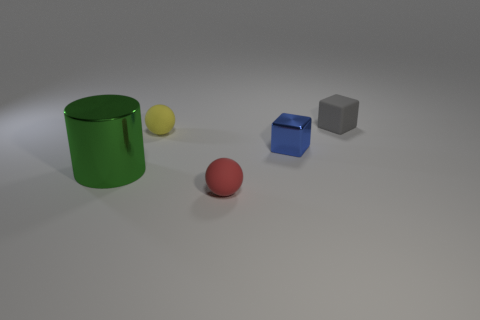Are there any other things that are the same size as the green metallic thing?
Offer a very short reply. No. Is there anything else that is the same shape as the large green metallic thing?
Your answer should be very brief. No. What number of cylinders are either red matte objects or blue metallic objects?
Provide a short and direct response. 0. There is a matte ball that is in front of the small blue block; is it the same color as the cylinder?
Your answer should be compact. No. The tiny ball that is on the left side of the ball that is in front of the ball that is behind the big green metallic cylinder is made of what material?
Provide a short and direct response. Rubber. Does the blue shiny block have the same size as the red ball?
Give a very brief answer. Yes. There is a metallic block; is its color the same as the small object that is behind the yellow sphere?
Provide a short and direct response. No. There is a blue thing that is made of the same material as the large green cylinder; what is its shape?
Give a very brief answer. Cube. There is a small rubber object in front of the metal cylinder; is it the same shape as the green object?
Give a very brief answer. No. There is a rubber ball that is right of the sphere behind the red sphere; how big is it?
Offer a terse response. Small. 